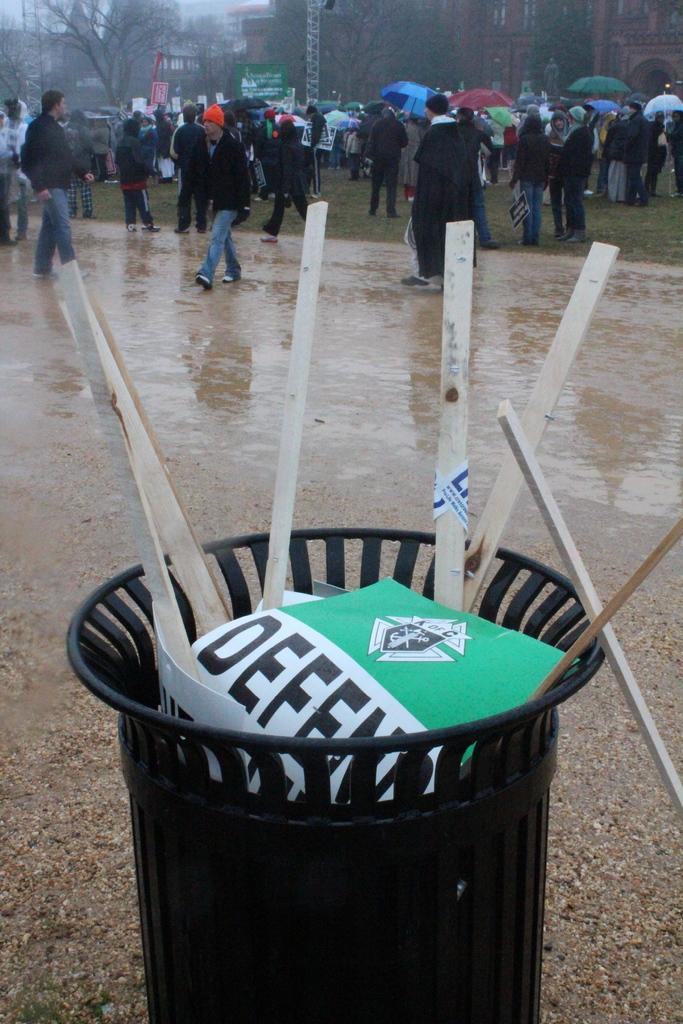<image>
Provide a brief description of the given image. many people are standing behind a trash can with DEFEND signs in it 